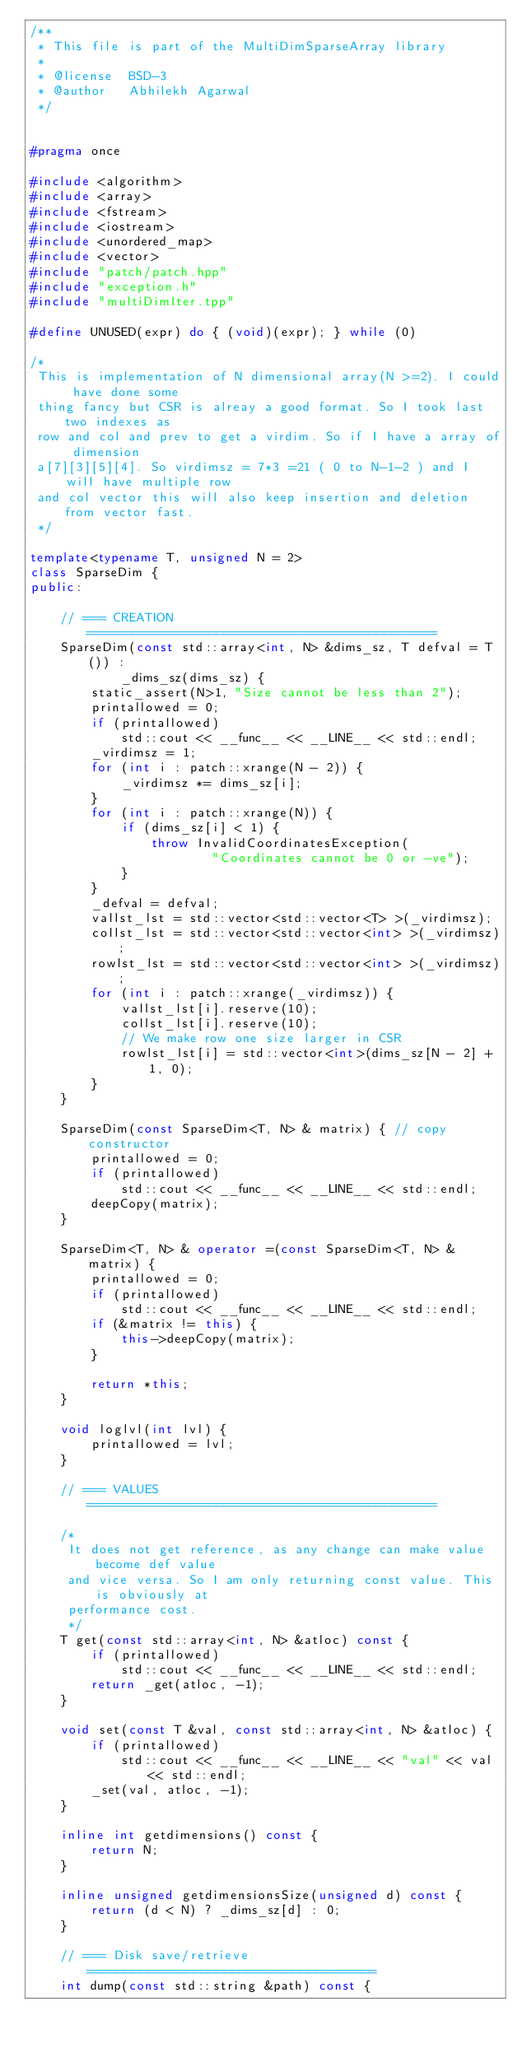<code> <loc_0><loc_0><loc_500><loc_500><_C++_>/**
 * This file is part of the MultiDimSparseArray library
 *
 * @license  BSD-3
 * @author   Abhilekh Agarwal
 */


#pragma once

#include <algorithm>
#include <array>
#include <fstream>
#include <iostream>
#include <unordered_map>
#include <vector>
#include "patch/patch.hpp"
#include "exception.h"
#include "multiDimIter.tpp"

#define UNUSED(expr) do { (void)(expr); } while (0)

/*
 This is implementation of N dimensional array(N >=2). I could have done some
 thing fancy but CSR is alreay a good format. So I took last two indexes as
 row and col and prev to get a virdim. So if I have a array of dimension
 a[7][3][5][4]. So virdimsz = 7*3 =21 ( 0 to N-1-2 ) and I will have multiple row
 and col vector this will also keep insertion and deletion from vector fast.
 */

template<typename T, unsigned N = 2>
class SparseDim {
public:

    // === CREATION ==============================================
    SparseDim(const std::array<int, N> &dims_sz, T defval = T()) :
            _dims_sz(dims_sz) {
        static_assert(N>1, "Size cannot be less than 2");
        printallowed = 0;
        if (printallowed)
            std::cout << __func__ << __LINE__ << std::endl;
        _virdimsz = 1;
        for (int i : patch::xrange(N - 2)) {
            _virdimsz *= dims_sz[i];
        }
        for (int i : patch::xrange(N)) {
            if (dims_sz[i] < 1) {
                throw InvalidCoordinatesException(
                        "Coordinates cannot be 0 or -ve");
            }
        }
        _defval = defval;
        vallst_lst = std::vector<std::vector<T> >(_virdimsz);
        collst_lst = std::vector<std::vector<int> >(_virdimsz);
        rowlst_lst = std::vector<std::vector<int> >(_virdimsz);
        for (int i : patch::xrange(_virdimsz)) {
            vallst_lst[i].reserve(10);
            collst_lst[i].reserve(10);
            // We make row one size larger in CSR
            rowlst_lst[i] = std::vector<int>(dims_sz[N - 2] + 1, 0);
        }
    }

    SparseDim(const SparseDim<T, N> & matrix) { // copy constructor
        printallowed = 0;
        if (printallowed)
            std::cout << __func__ << __LINE__ << std::endl;
        deepCopy(matrix);
    }

    SparseDim<T, N> & operator =(const SparseDim<T, N> & matrix) {
        printallowed = 0;
        if (printallowed)
            std::cout << __func__ << __LINE__ << std::endl;
        if (&matrix != this) {
            this->deepCopy(matrix);
        }

        return *this;
    }

    void loglvl(int lvl) {
        printallowed = lvl;
    }

    // === VALUES ==============================================

    /*
     It does not get reference, as any change can make value become def value
     and vice versa. So I am only returning const value. This is obviously at
     performance cost.
     */
    T get(const std::array<int, N> &atloc) const {
        if (printallowed)
            std::cout << __func__ << __LINE__ << std::endl;
        return _get(atloc, -1);
    }

    void set(const T &val, const std::array<int, N> &atloc) {
        if (printallowed)
            std::cout << __func__ << __LINE__ << "val" << val << std::endl;
        _set(val, atloc, -1);
    }

    inline int getdimensions() const {
        return N;
    }

    inline unsigned getdimensionsSize(unsigned d) const {
        return (d < N) ? _dims_sz[d] : 0;
    }

    // === Disk save/retrieve ======================================
    int dump(const std::string &path) const {</code> 